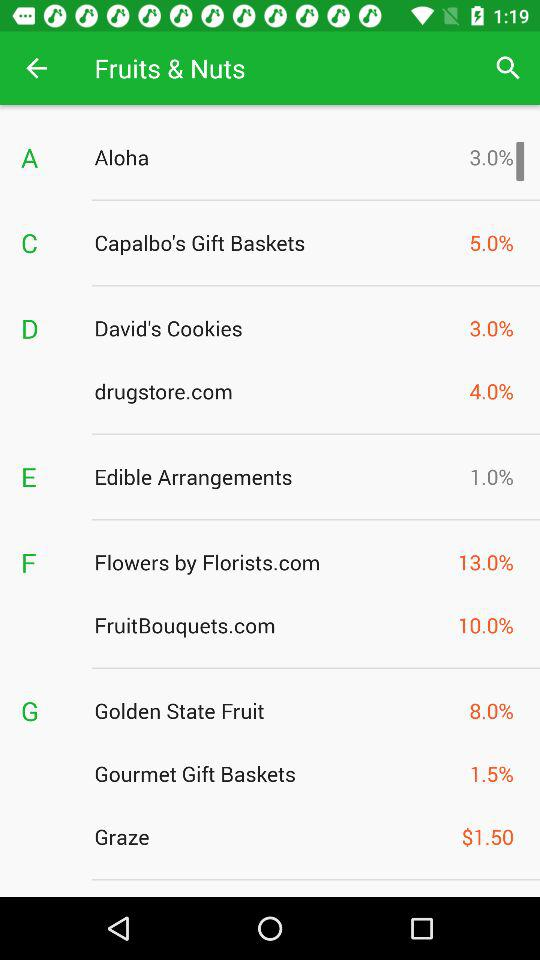Which of the following has a higher commission rate: Capalbo's Gift Baskets or Flowers by Florists.com?
Answer the question using a single word or phrase. Flowers by Florists.com 